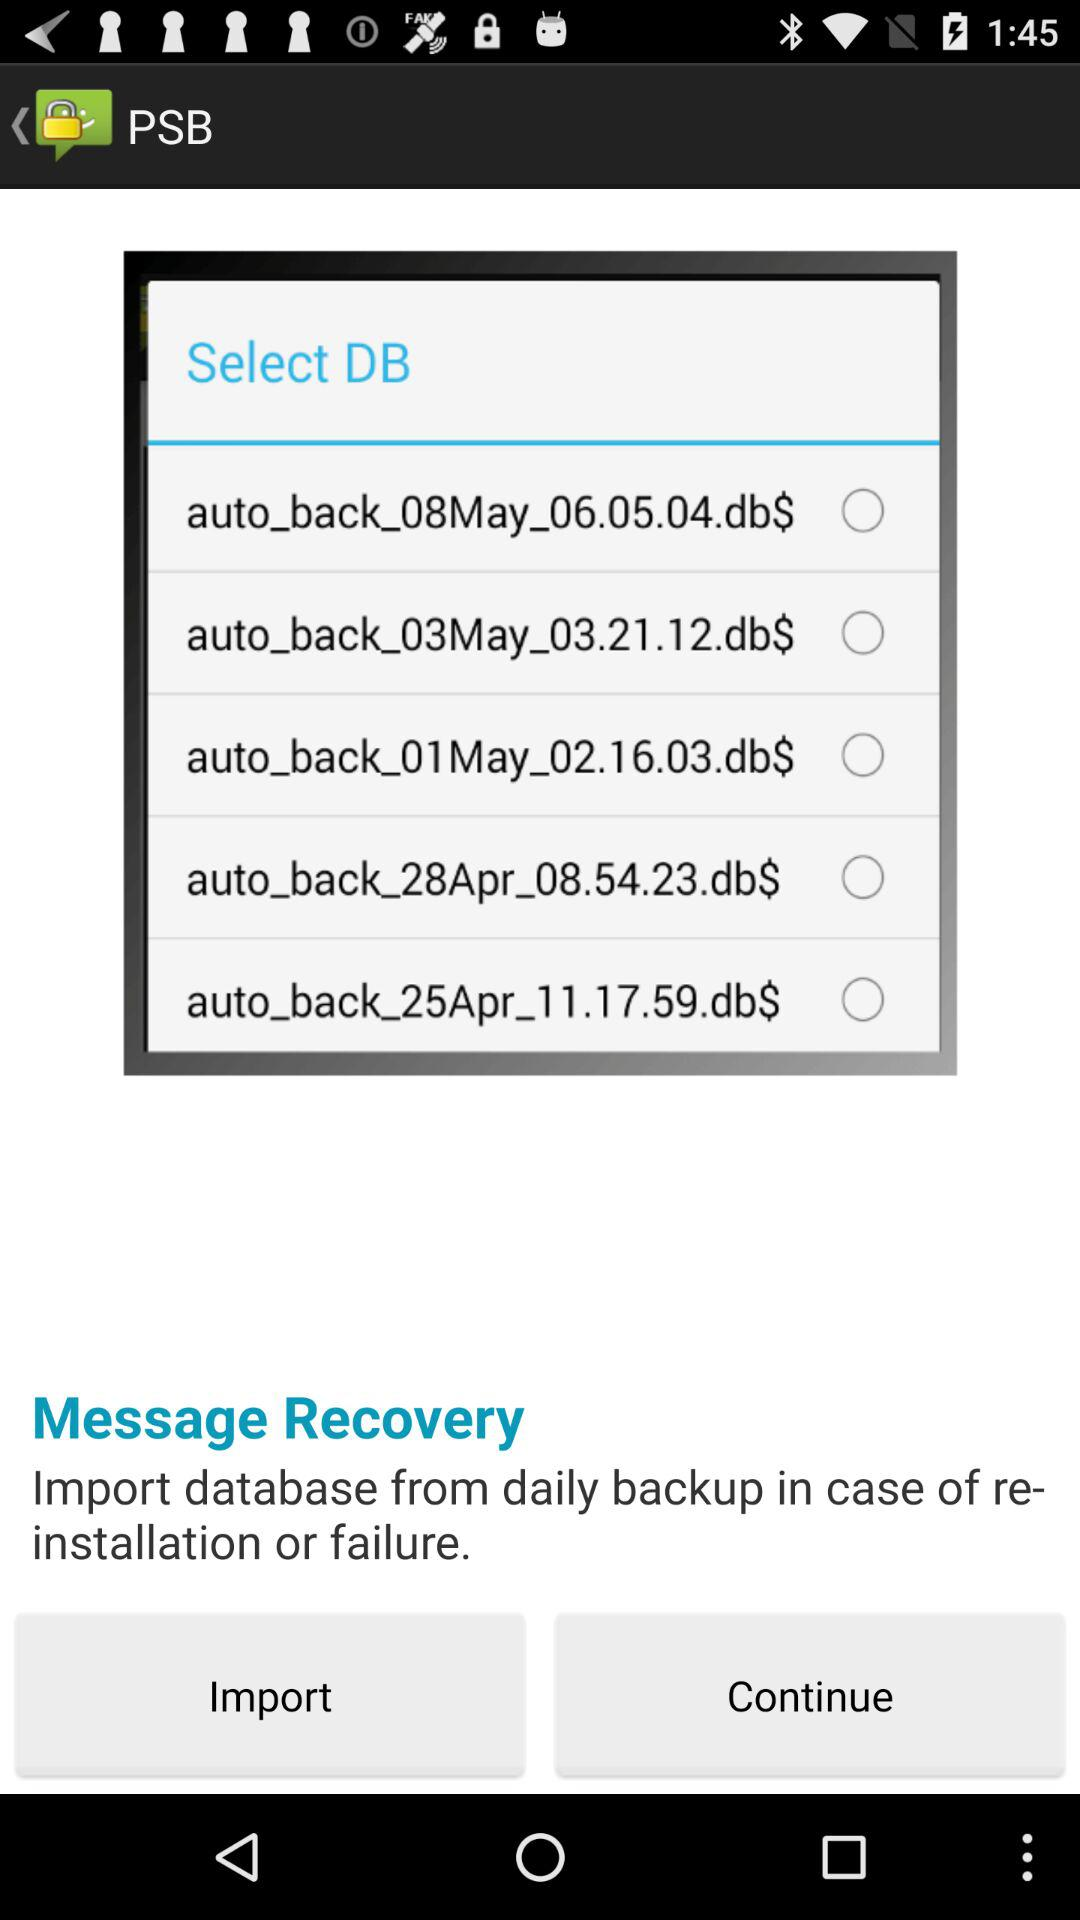How many days are represented by the available backup files? 5 